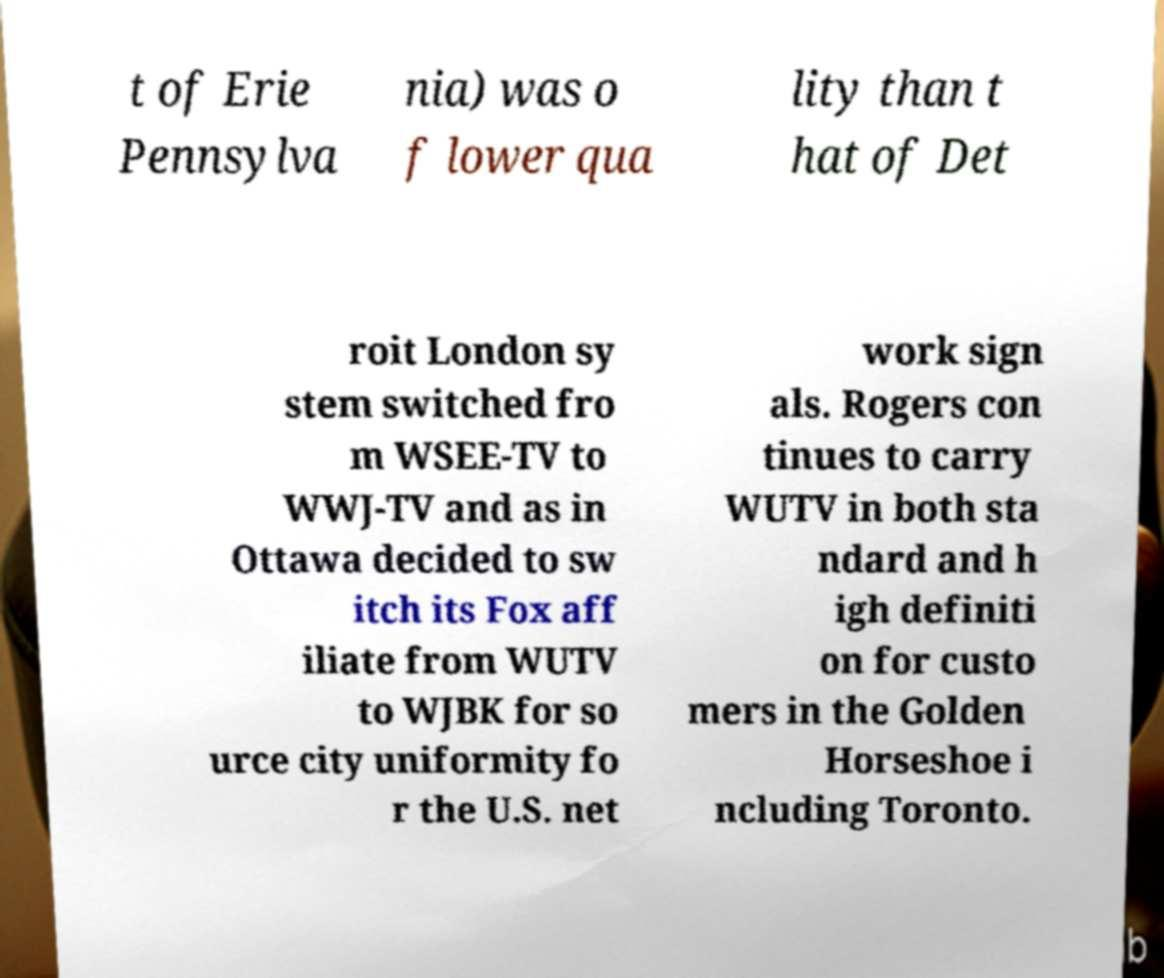Please identify and transcribe the text found in this image. t of Erie Pennsylva nia) was o f lower qua lity than t hat of Det roit London sy stem switched fro m WSEE-TV to WWJ-TV and as in Ottawa decided to sw itch its Fox aff iliate from WUTV to WJBK for so urce city uniformity fo r the U.S. net work sign als. Rogers con tinues to carry WUTV in both sta ndard and h igh definiti on for custo mers in the Golden Horseshoe i ncluding Toronto. 